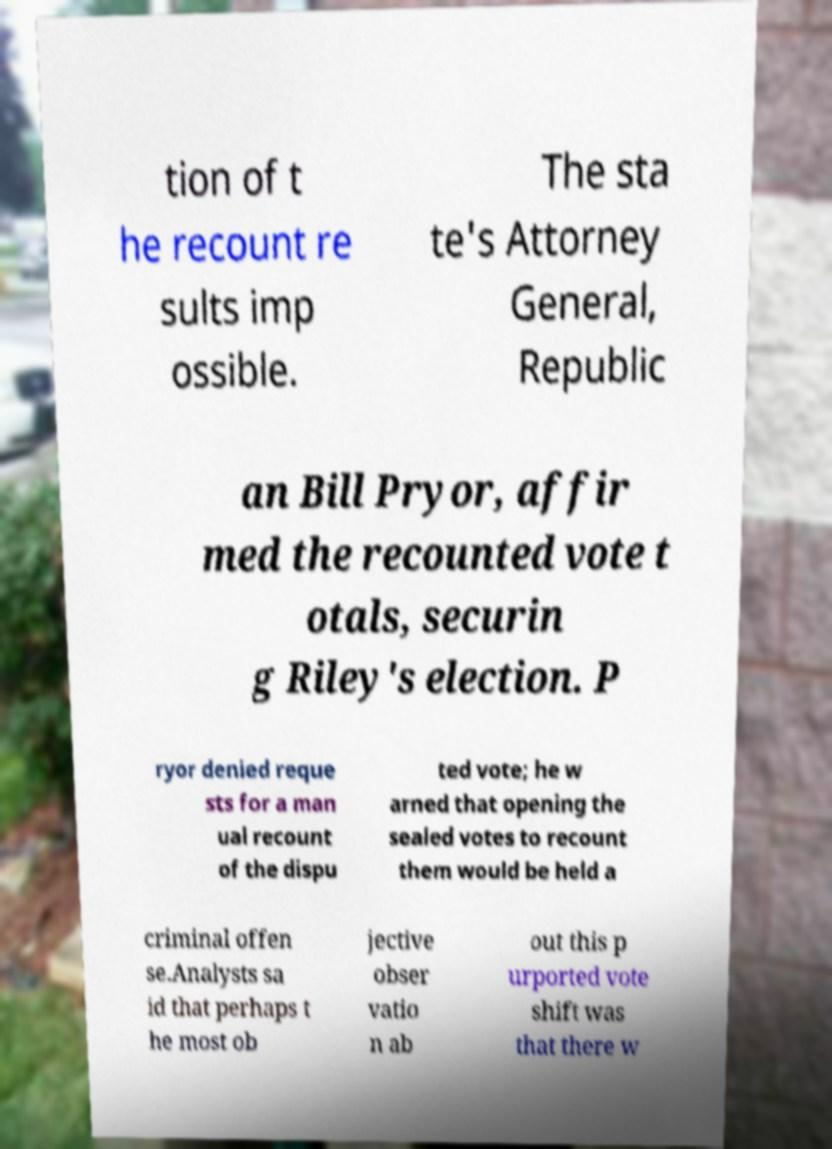For documentation purposes, I need the text within this image transcribed. Could you provide that? tion of t he recount re sults imp ossible. The sta te's Attorney General, Republic an Bill Pryor, affir med the recounted vote t otals, securin g Riley's election. P ryor denied reque sts for a man ual recount of the dispu ted vote; he w arned that opening the sealed votes to recount them would be held a criminal offen se.Analysts sa id that perhaps t he most ob jective obser vatio n ab out this p urported vote shift was that there w 